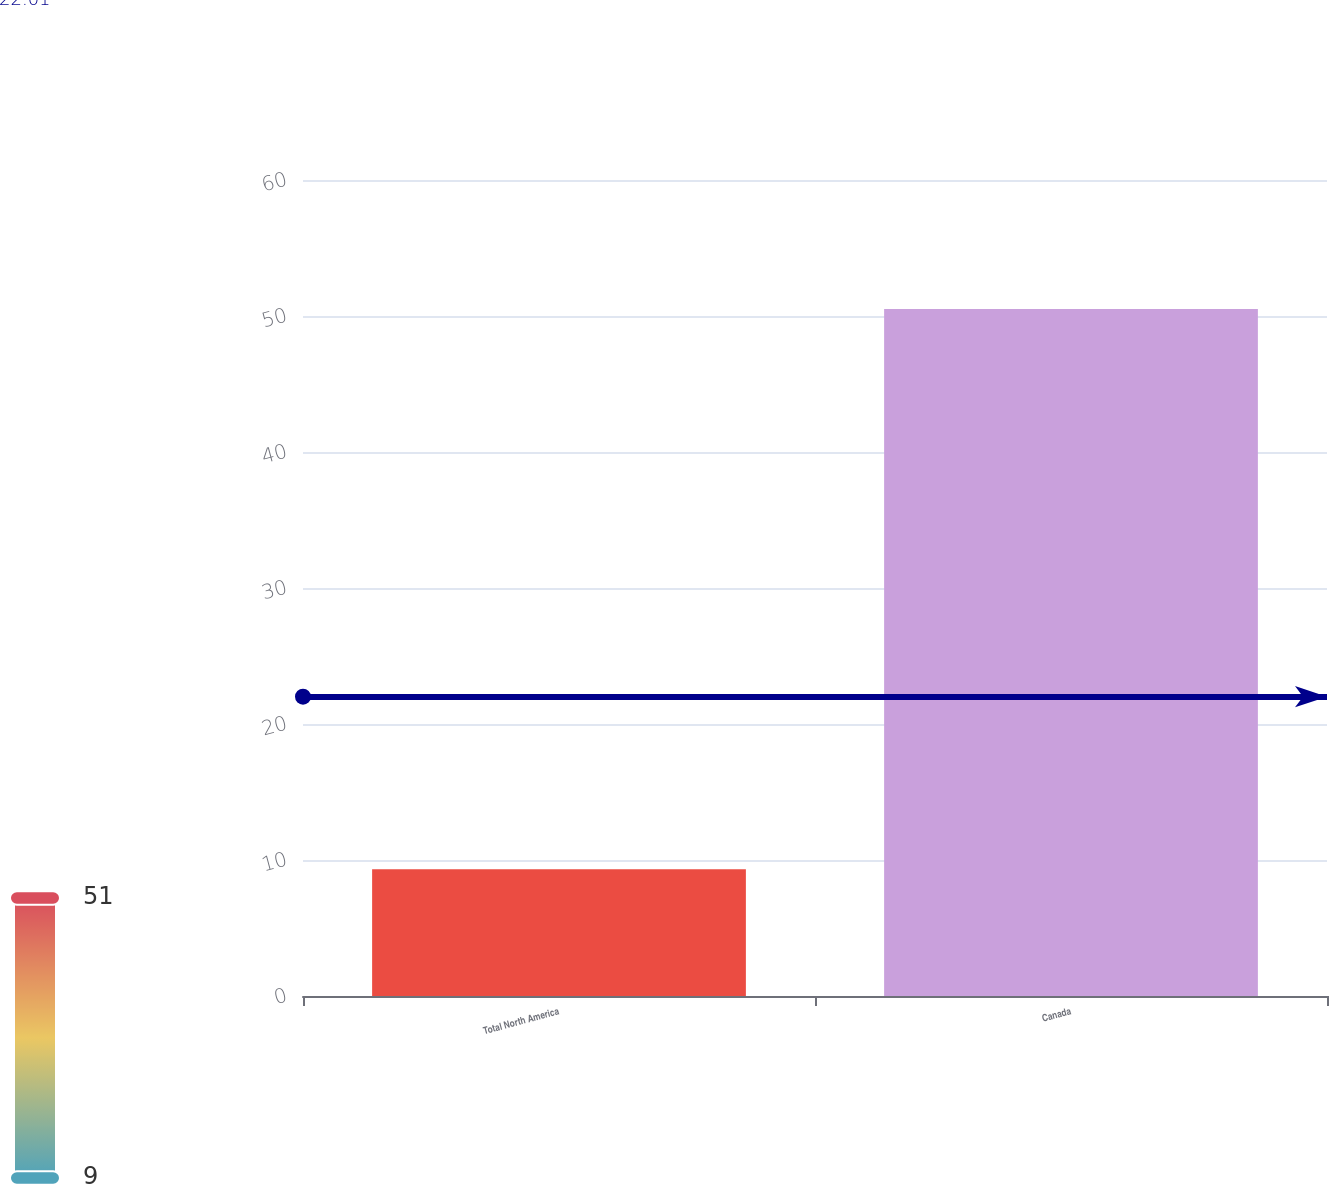Convert chart to OTSL. <chart><loc_0><loc_0><loc_500><loc_500><bar_chart><fcel>Total North America<fcel>Canada<nl><fcel>9.32<fcel>50.52<nl></chart> 